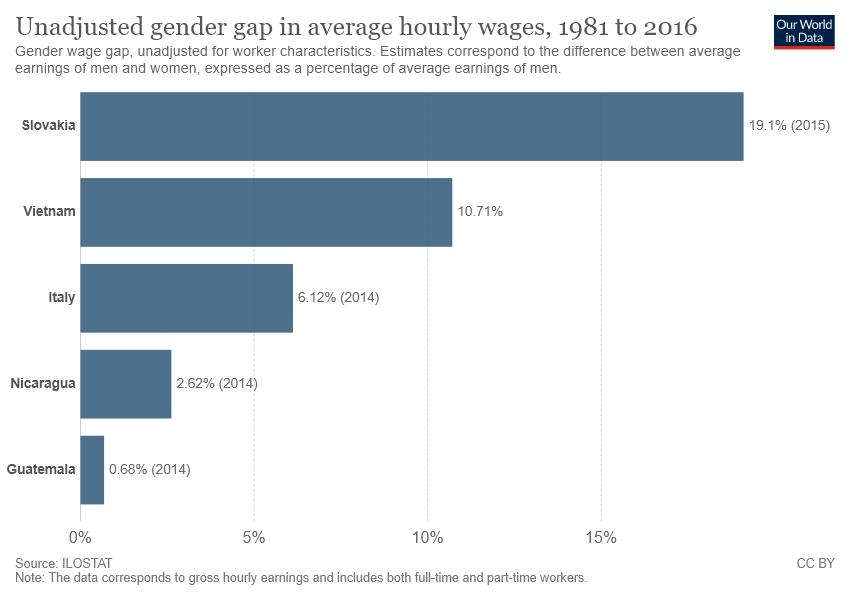Specify some key components in this picture. The sum of the lowest three bars is not greater than Vietnam. The place with the largest unadjusted gender gap is Italy, with a score of 6.12. 